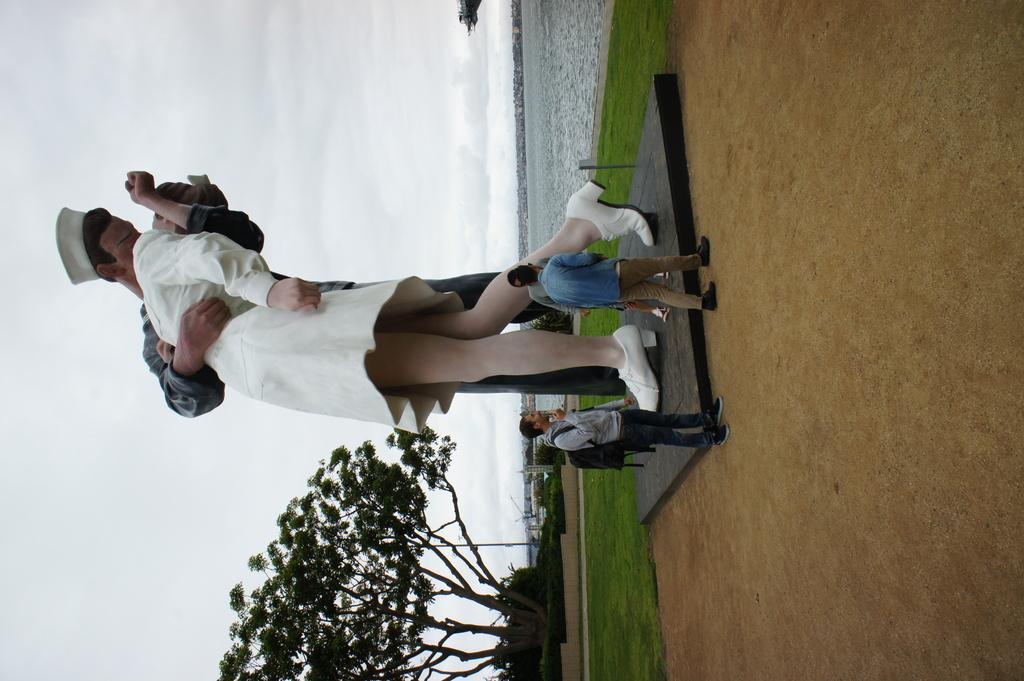What is the main subject in the image? There is a statue in the image. Are there any other subjects or objects in the image? Yes, there are people in the image. What type of vegetation is present at the bottom of the image? There is a tree at the bottom of the image. What can be seen in the background of the image? Water and the sky are visible in the background of the image. What type of mask is being worn by the statue in the image? There is no mask present on the statue in the image. What type of field can be seen in the image? There is no field present in the image. 